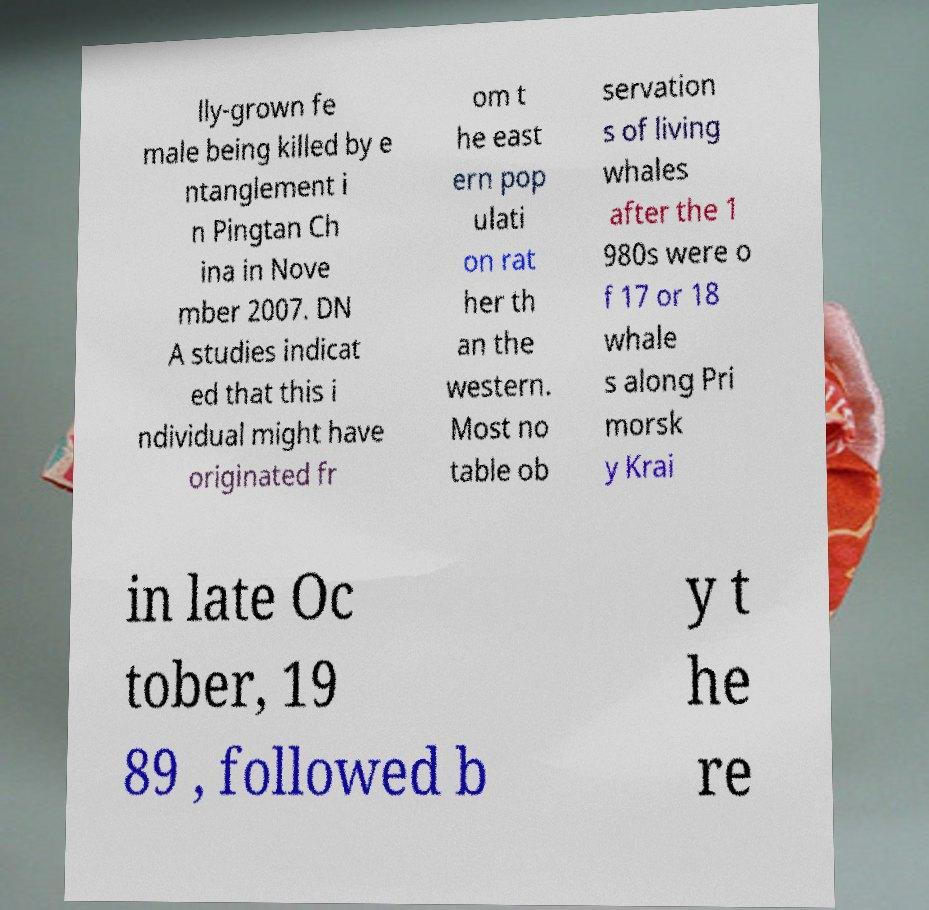What messages or text are displayed in this image? I need them in a readable, typed format. lly-grown fe male being killed by e ntanglement i n Pingtan Ch ina in Nove mber 2007. DN A studies indicat ed that this i ndividual might have originated fr om t he east ern pop ulati on rat her th an the western. Most no table ob servation s of living whales after the 1 980s were o f 17 or 18 whale s along Pri morsk y Krai in late Oc tober, 19 89 , followed b y t he re 